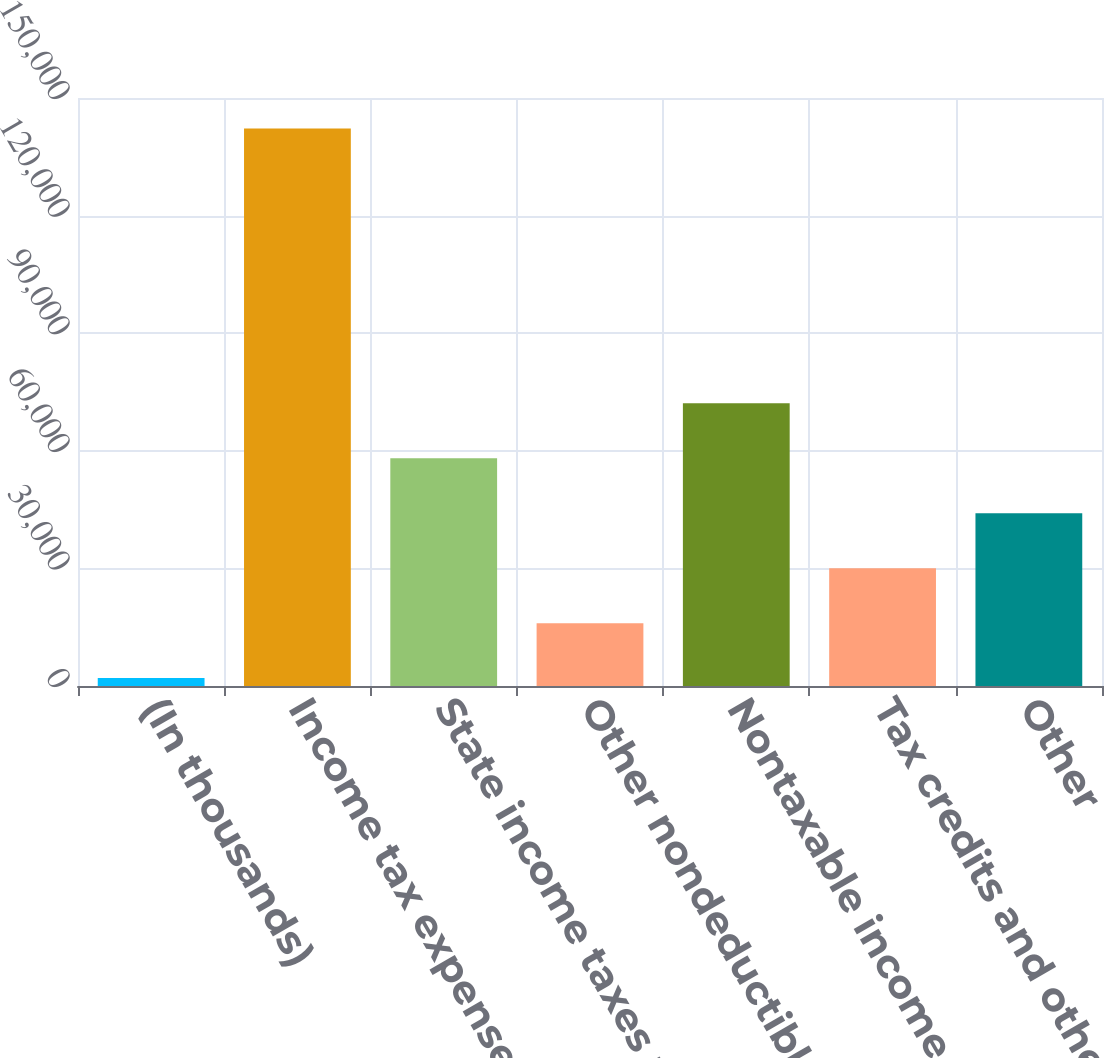<chart> <loc_0><loc_0><loc_500><loc_500><bar_chart><fcel>(In thousands)<fcel>Income tax expense at<fcel>State income taxes net<fcel>Other nondeductible expenses<fcel>Nontaxable income<fcel>Tax credits and other taxes<fcel>Other<nl><fcel>2013<fcel>142251<fcel>58108.2<fcel>16036.8<fcel>72132<fcel>30060.6<fcel>44084.4<nl></chart> 